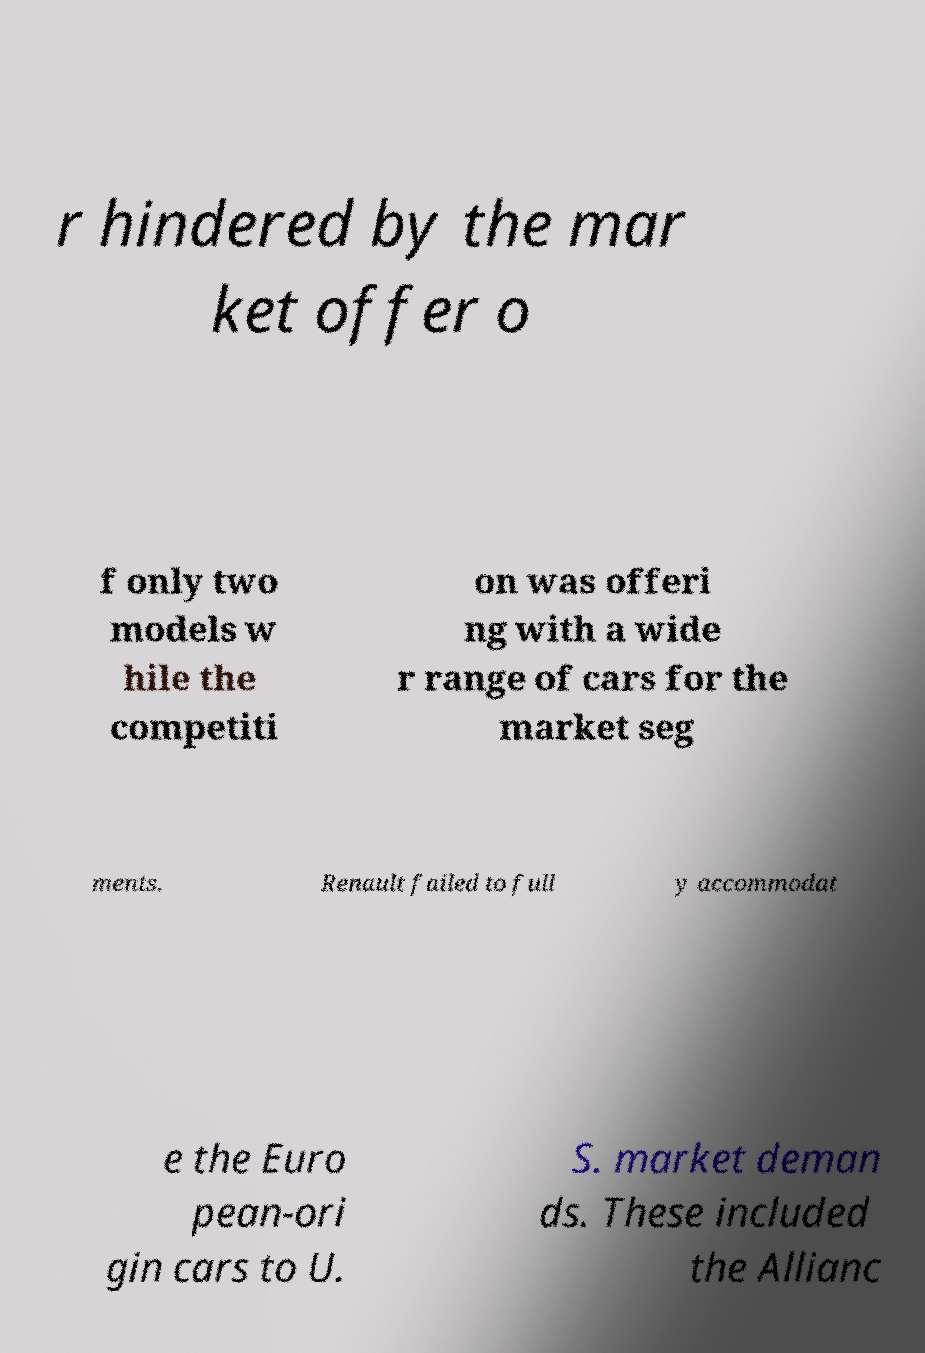Could you extract and type out the text from this image? r hindered by the mar ket offer o f only two models w hile the competiti on was offeri ng with a wide r range of cars for the market seg ments. Renault failed to full y accommodat e the Euro pean-ori gin cars to U. S. market deman ds. These included the Allianc 